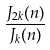Convert formula to latex. <formula><loc_0><loc_0><loc_500><loc_500>\frac { J _ { 2 k } ( n ) } { J _ { k } ( n ) }</formula> 